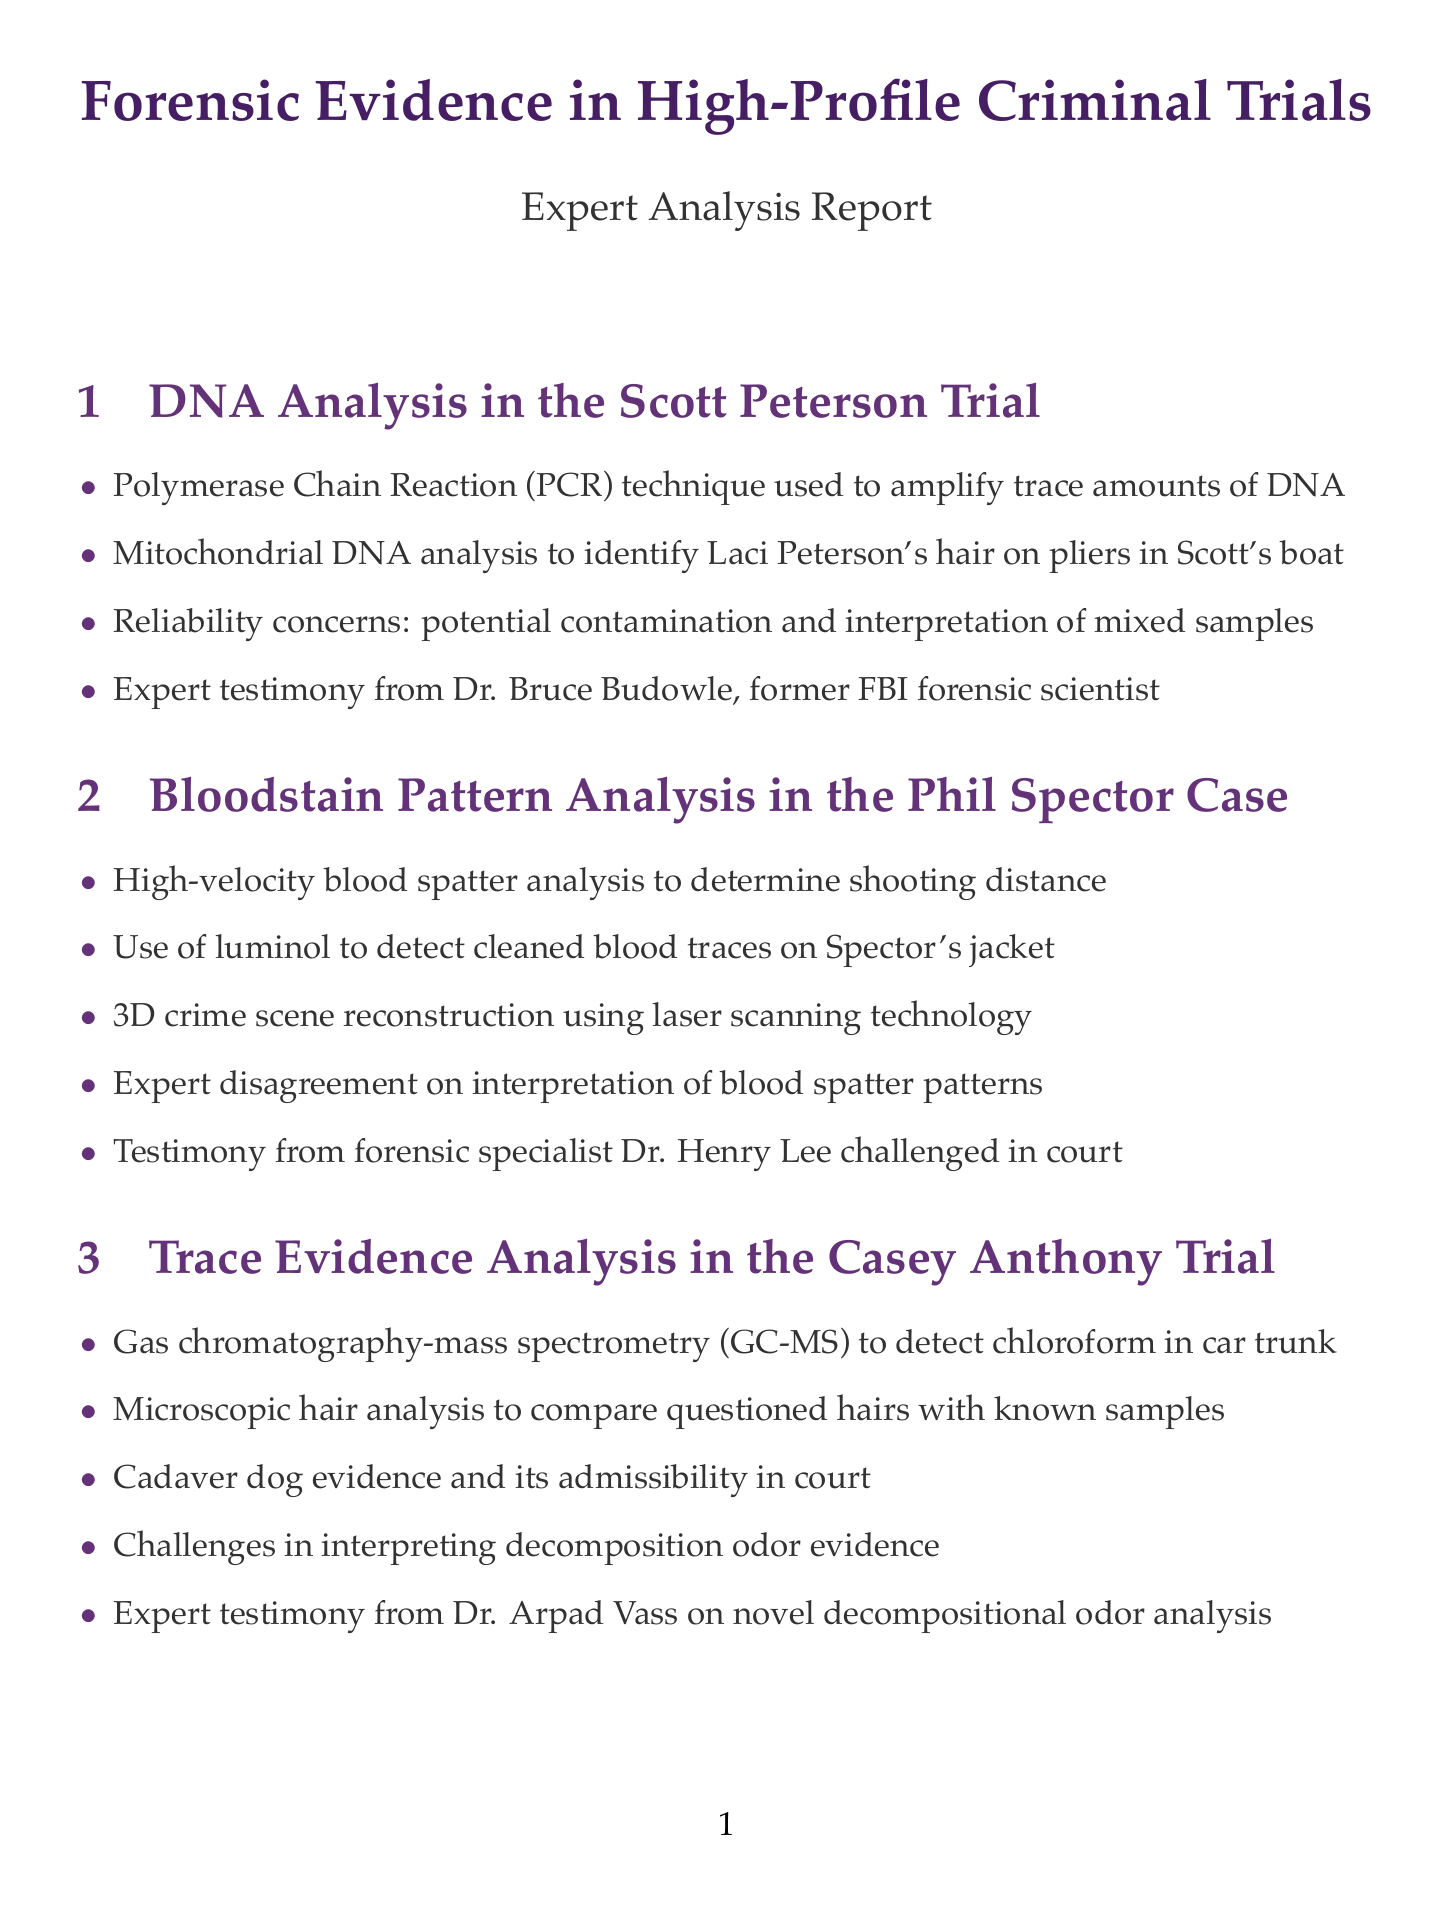What scientific method was used in the Scott Peterson Trial? The document mentions the Polymerase Chain Reaction (PCR) technique as a scientific method used in the Scott Peterson Trial.
Answer: Polymerase Chain Reaction (PCR) Who provided expert testimony in the Aaron Hernandez Trial? The document states that firearms expert Kyle Aspinwall provided testimony in the Aaron Hernandez Trial.
Answer: Kyle Aspinwall What forensic technique was used to detect chloroform in the Casey Anthony Trial? The document indicates that Gas chromatography-mass spectrometry (GC-MS) was used to detect chloroform.
Answer: Gas chromatography-mass spectrometry (GC-MS) What is a challenge related to digital evidence mentioned in the Jodi Arias Case? The document highlights challenges in preserving digital evidence integrity as a significant issue in the Jodi Arias Case.
Answer: Preserving digital evidence integrity Which trial involved expert Dr. Henry Lee? According to the document, Dr. Henry Lee was involved in the Phil Spector Case regarding bloodstain pattern analysis.
Answer: Phil Spector Case What kind of analysis was disputed in the Phil Spector Case? The document notes that there was expert disagreement on the interpretation of blood spatter patterns in the Phil Spector Case.
Answer: Interpretation of blood spatter patterns What is a reliability concern in DNA analysis? The document clearly states that potential contamination is a reliability concern in DNA analysis.
Answer: Potential contamination 